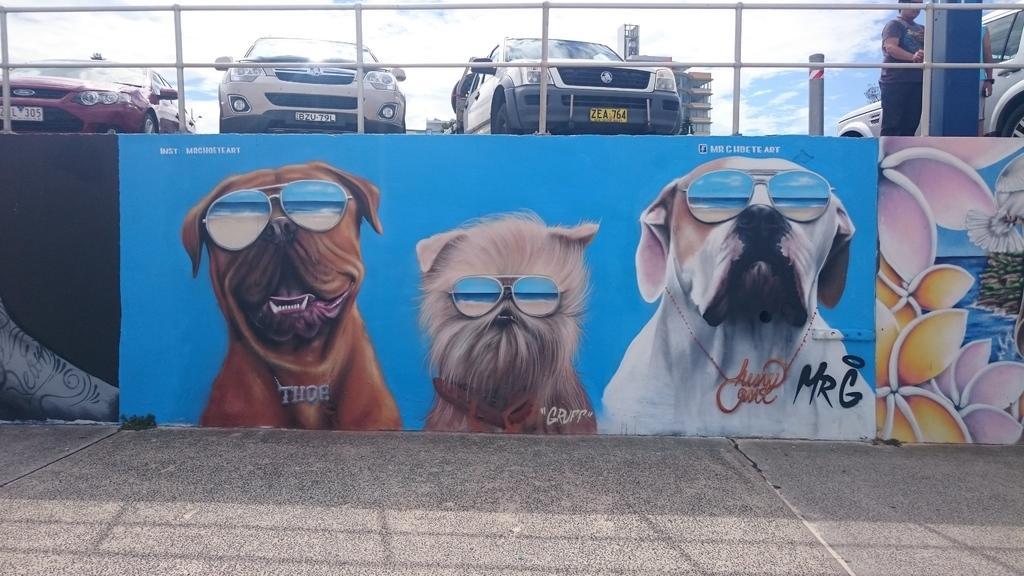Describe this image in one or two sentences. This picture shows few dog and flower paintings on the wall and we see a metal fence and we see couple of them standing and we see buildings and a blue cloudy sky. 